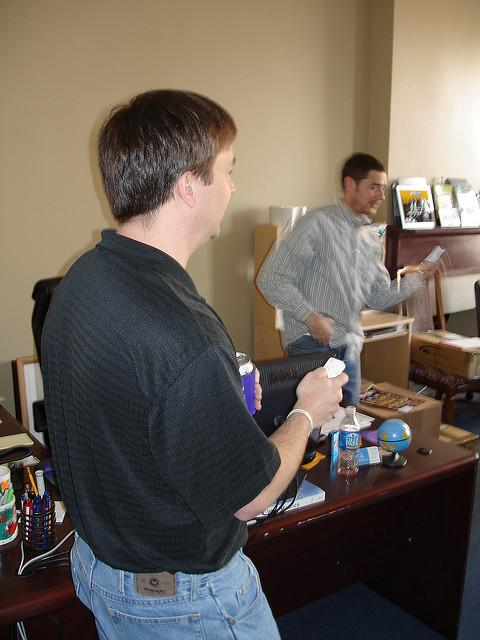What is the blue round object sitting on the desk a model of?

Choices:
A) planet
B) gyroscope
C) moon
D) globe globe 